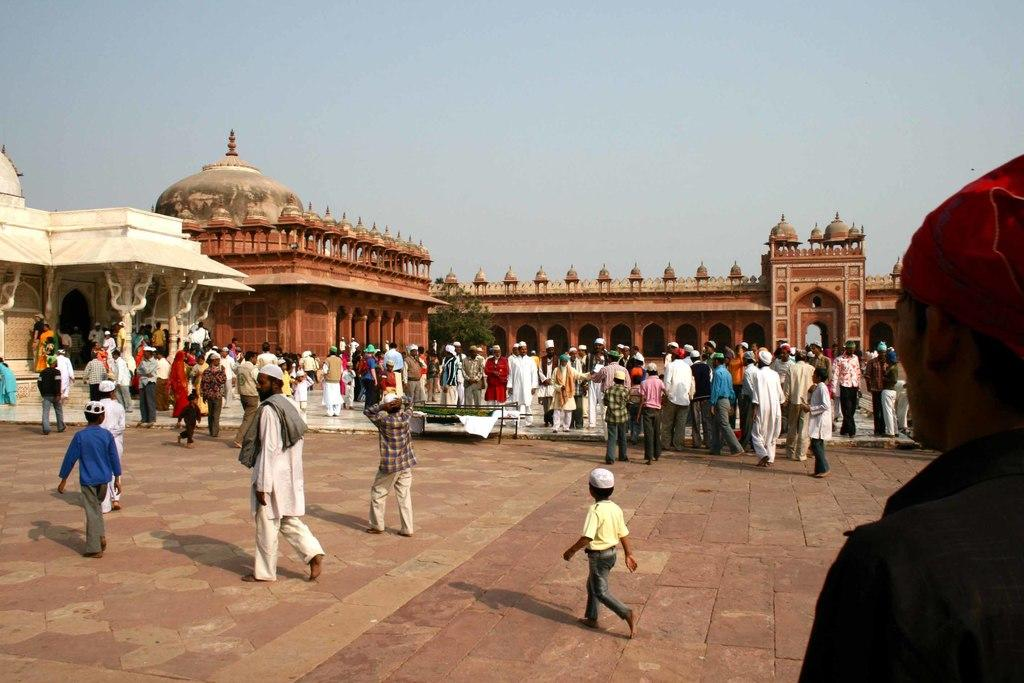What can be seen in the image that people walk on? There is a path in the image that people walk on. Can you describe the people in the image? There are people on the path in the image. What can be seen in the distance behind the people? There are monuments in the background of the image. What type of vegetation is visible in the image? There are leaves visible in the image. How would you describe the weather based on the image? The sky is clear in the image, suggesting good weather. What type of spy equipment can be seen in the image? There is no spy equipment present in the image. What form does the path take in the image? The path in the image is a straight line, but it does not have a specific form like a circle or triangle. 